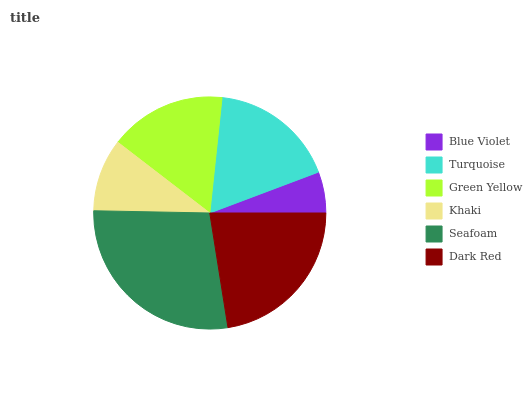Is Blue Violet the minimum?
Answer yes or no. Yes. Is Seafoam the maximum?
Answer yes or no. Yes. Is Turquoise the minimum?
Answer yes or no. No. Is Turquoise the maximum?
Answer yes or no. No. Is Turquoise greater than Blue Violet?
Answer yes or no. Yes. Is Blue Violet less than Turquoise?
Answer yes or no. Yes. Is Blue Violet greater than Turquoise?
Answer yes or no. No. Is Turquoise less than Blue Violet?
Answer yes or no. No. Is Turquoise the high median?
Answer yes or no. Yes. Is Green Yellow the low median?
Answer yes or no. Yes. Is Dark Red the high median?
Answer yes or no. No. Is Turquoise the low median?
Answer yes or no. No. 